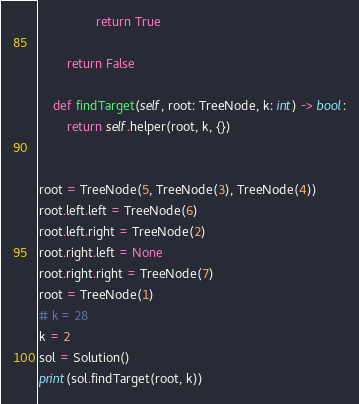<code> <loc_0><loc_0><loc_500><loc_500><_Python_>                return True

        return False

    def findTarget(self, root: TreeNode, k: int) -> bool:
        return self.helper(root, k, {})


root = TreeNode(5, TreeNode(3), TreeNode(4))
root.left.left = TreeNode(6)
root.left.right = TreeNode(2)
root.right.left = None
root.right.right = TreeNode(7)
root = TreeNode(1)
# k = 28
k = 2
sol = Solution()
print(sol.findTarget(root, k))
</code> 